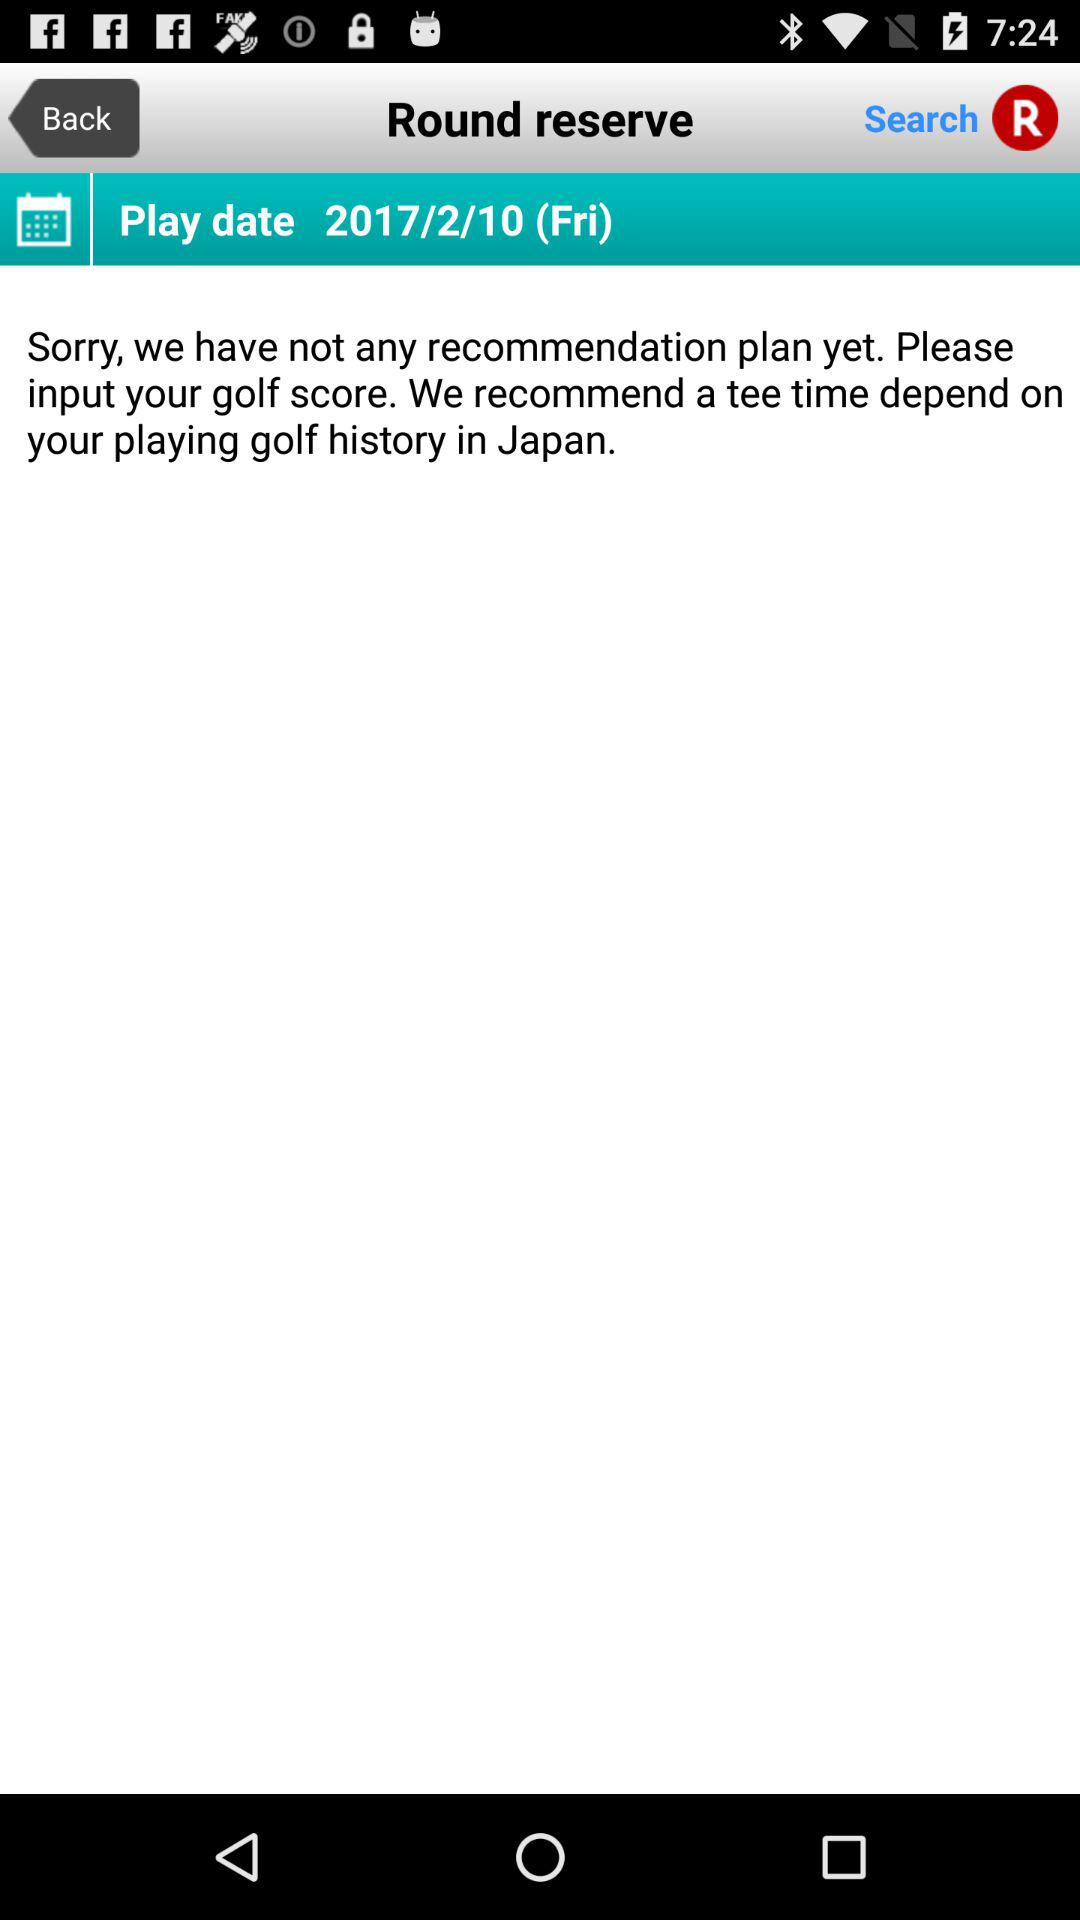What is the given play date? The given play date is Friday, February 10, 2017. 